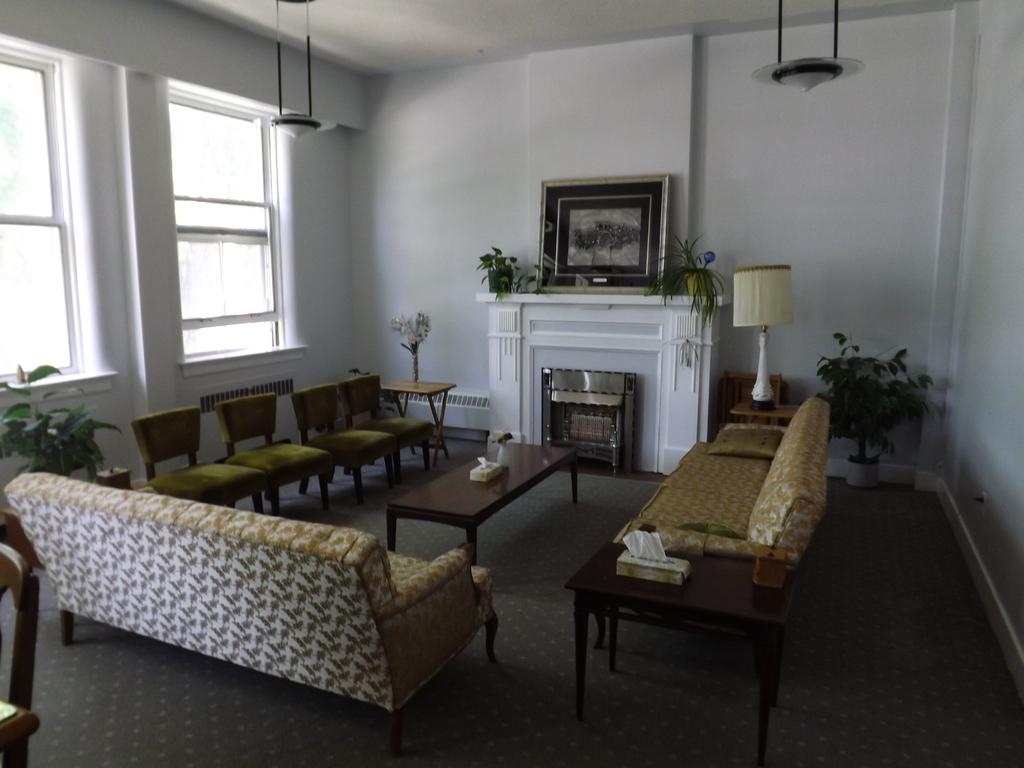What type of furniture is present in the room? There are sofas and chairs in the room. What type of decorative elements can be found in the room? There are houseplants, a frame on the wall, and a lamp in the room. What is used for seating and relaxation in the room? The sofas and chairs are used for seating and relaxation in the room. What is used for displaying items or for placing objects in the room? There is a table in the room for displaying items or placing objects. How is natural light brought into the room? There are windows in the room that allow natural light to enter. What is used for providing illumination in the room? There are lights in the room, including a lamp, for providing illumination. How is the dirt being used in the room? There is no dirt present in the room; it is a clean indoor space. What type of string is being used to hold the frame on the wall? There is no string visible in the image, and the frame is securely mounted on the wall. 